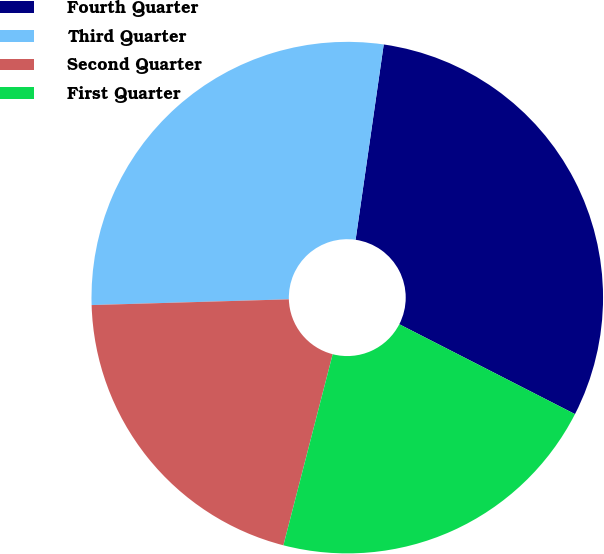Convert chart to OTSL. <chart><loc_0><loc_0><loc_500><loc_500><pie_chart><fcel>Fourth Quarter<fcel>Third Quarter<fcel>Second Quarter<fcel>First Quarter<nl><fcel>30.25%<fcel>27.74%<fcel>20.52%<fcel>21.49%<nl></chart> 